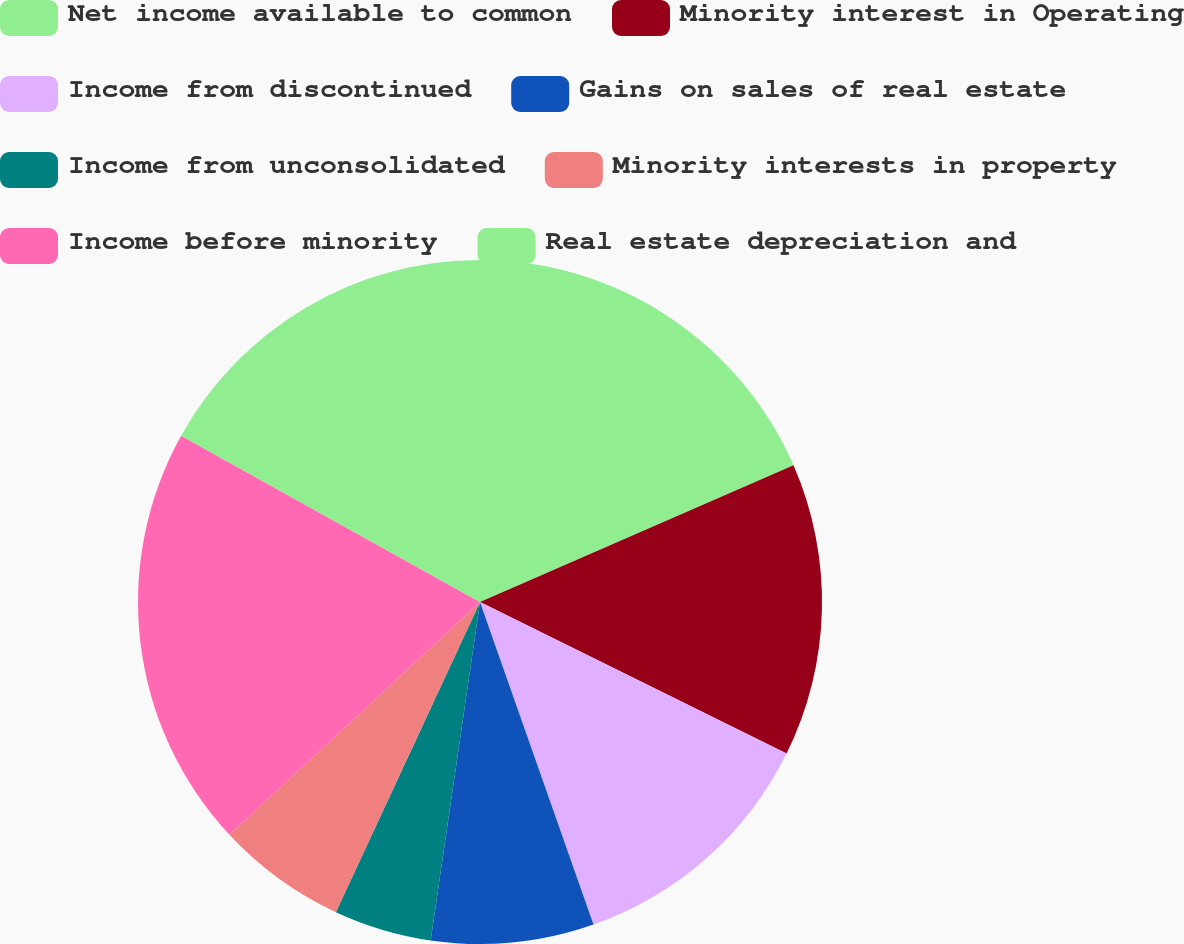Convert chart. <chart><loc_0><loc_0><loc_500><loc_500><pie_chart><fcel>Net income available to common<fcel>Minority interest in Operating<fcel>Income from discontinued<fcel>Gains on sales of real estate<fcel>Income from unconsolidated<fcel>Minority interests in property<fcel>Income before minority<fcel>Real estate depreciation and<nl><fcel>18.46%<fcel>13.85%<fcel>12.31%<fcel>7.69%<fcel>4.62%<fcel>6.16%<fcel>20.0%<fcel>16.92%<nl></chart> 